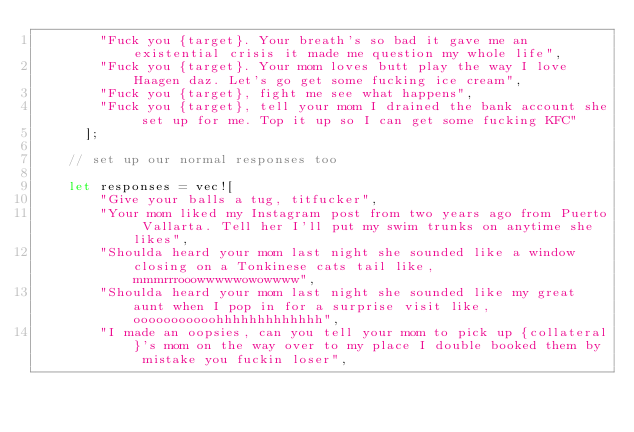<code> <loc_0><loc_0><loc_500><loc_500><_Rust_>        "Fuck you {target}. Your breath's so bad it gave me an existential crisis it made me question my whole life",
        "Fuck you {target}. Your mom loves butt play the way I love Haagen daz. Let's go get some fucking ice cream",
        "Fuck you {target}, fight me see what happens",
        "Fuck you {target}, tell your mom I drained the bank account she set up for me. Top it up so I can get some fucking KFC"
      ];

    // set up our normal responses too

    let responses = vec![
        "Give your balls a tug, titfucker",
        "Your mom liked my Instagram post from two years ago from Puerto Vallarta. Tell her I'll put my swim trunks on anytime she likes",
        "Shoulda heard your mom last night she sounded like a window closing on a Tonkinese cats tail like, mmmrrrooowwwwwowowwww",
        "Shoulda heard your mom last night she sounded like my great aunt when I pop in for a surprise visit like, ooooooooooohhhhhhhhhhhhh",
        "I made an oopsies, can you tell your mom to pick up {collateral}'s mom on the way over to my place I double booked them by mistake you fuckin loser",</code> 